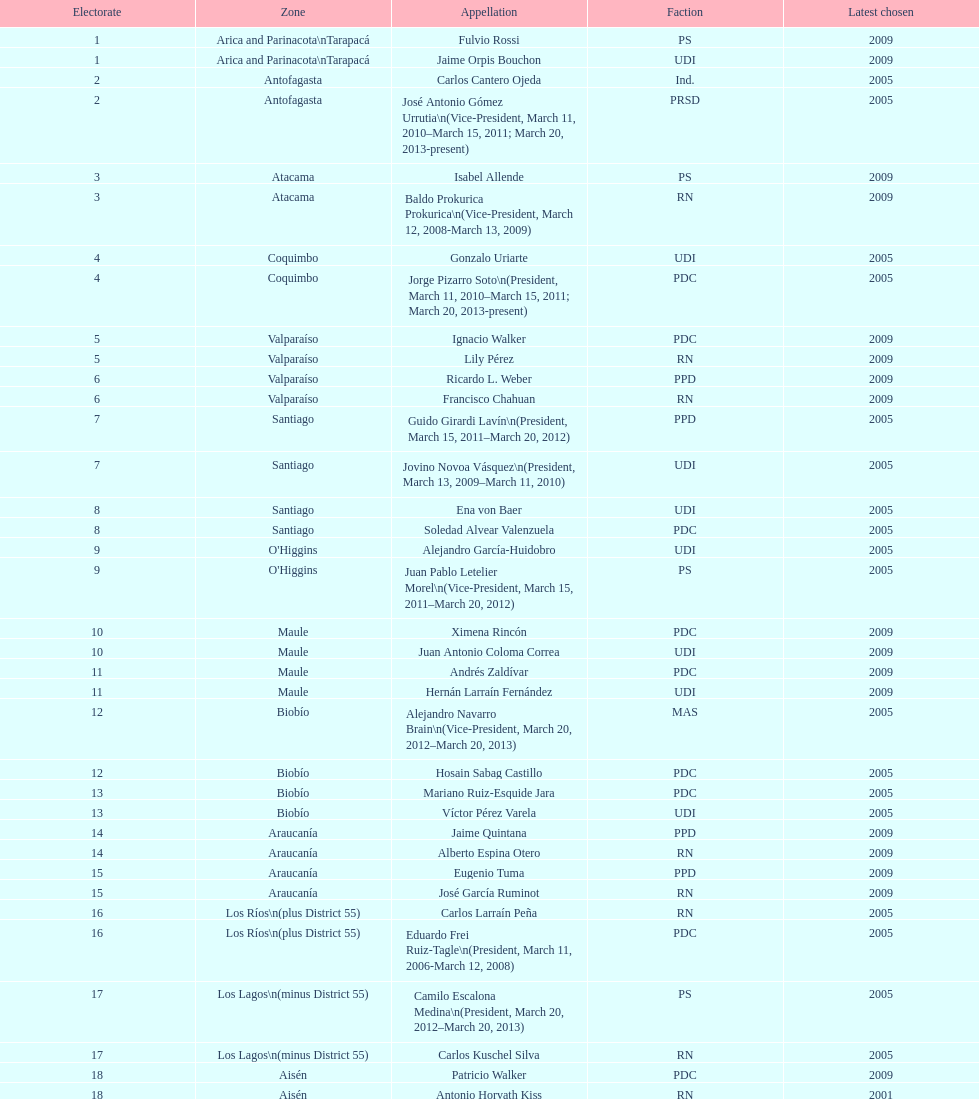What is the last region listed on the table? Magallanes. 